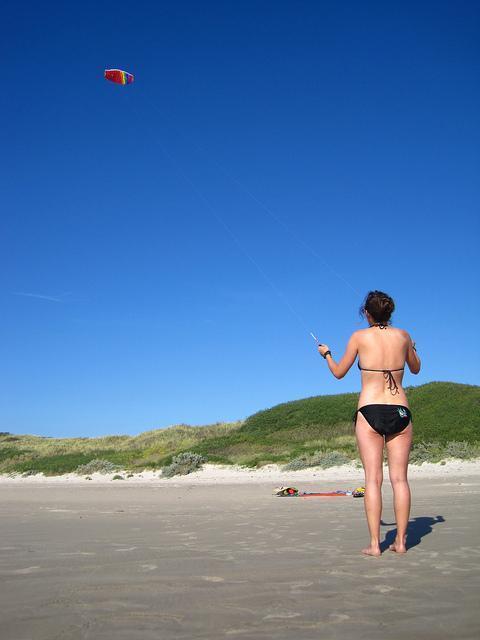How many people are in the picture?
Give a very brief answer. 1. How many people are there?
Give a very brief answer. 1. How many beds in this image require a ladder to get into?
Give a very brief answer. 0. 